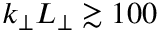<formula> <loc_0><loc_0><loc_500><loc_500>k _ { \perp } L _ { \perp } \gtrsim 1 0 0</formula> 